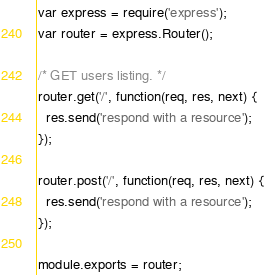Convert code to text. <code><loc_0><loc_0><loc_500><loc_500><_JavaScript_>var express = require('express');
var router = express.Router();

/* GET users listing. */
router.get('/', function(req, res, next) {
  res.send('respond with a resource');
});

router.post('/', function(req, res, next) {
  res.send('respond with a resource');
});

module.exports = router;
</code> 